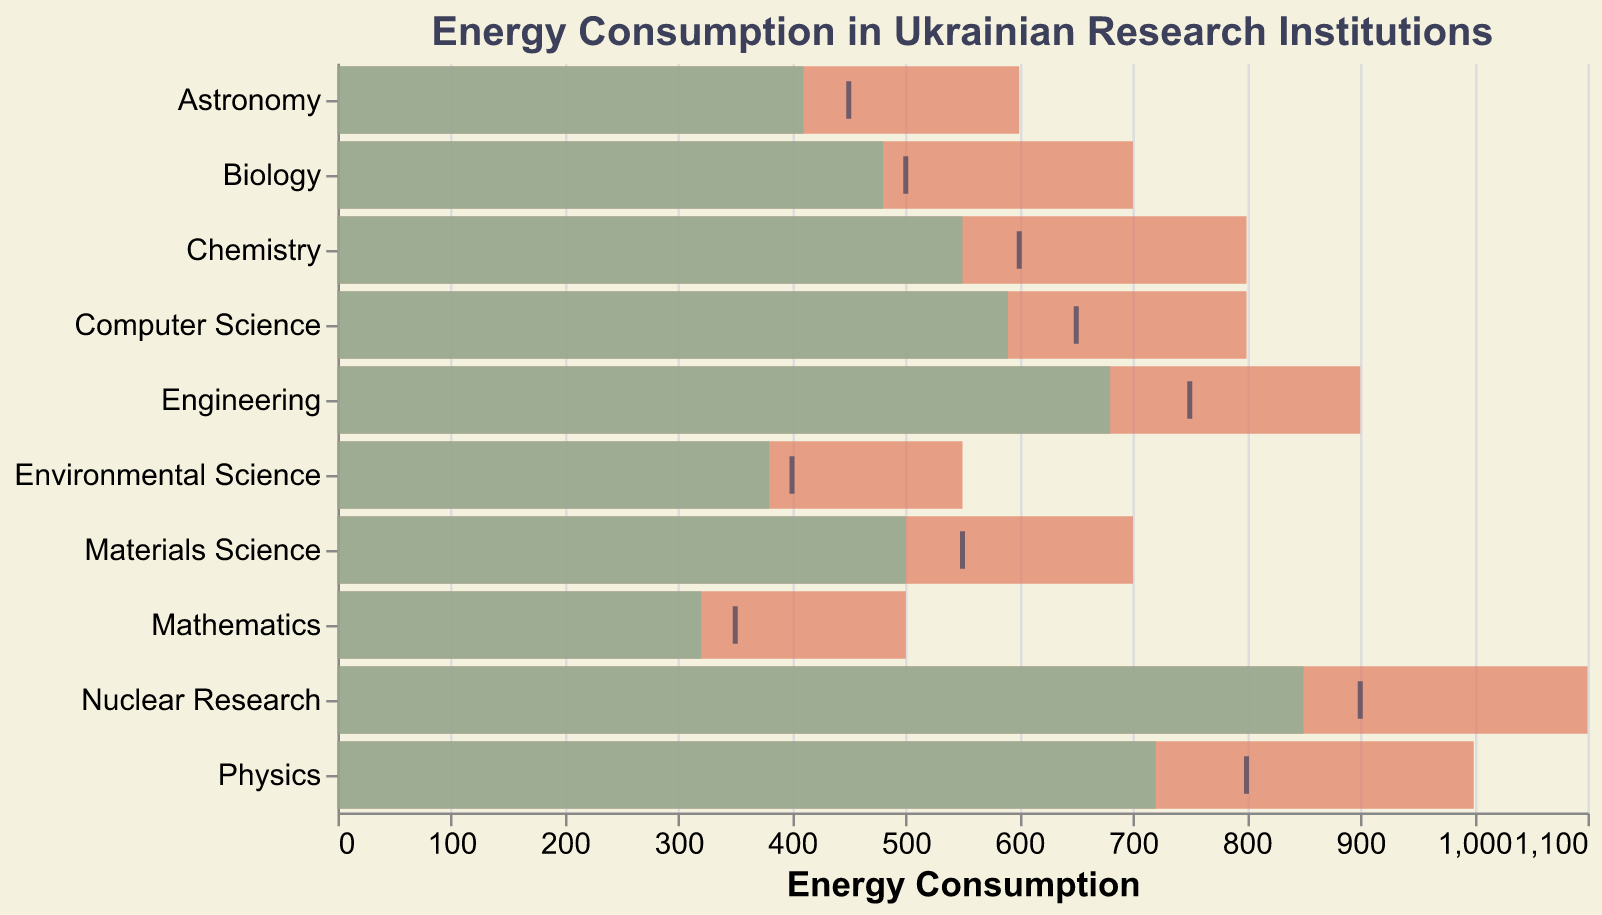What's the title of the chart? The title of the chart is usually located at the top and specifies what the chart is about. In this case, it's "Energy Consumption in Ukrainian Research Institutions".
Answer: Energy Consumption in Ukrainian Research Institutions Which department has the highest actual energy consumption? To determine which department has the highest energy consumption, look at the length of the green bars and find the one that extends the most to the right on the x-axis. Nuclear Research has the longest green bar.
Answer: Nuclear Research How much energy consumption is targeted for the Physics department? The target is marked by a black tick on the x-axis corresponding to the Physics department. The tick aligns with 800.
Answer: 800 By how much does the actual energy consumption for Environmental Science fall short of the target? Calculate the difference between the target and the actual values for Environmental Science. The target is 400, and the actual is 380. The difference is 400 - 380 = 20.
Answer: 20 Which department has an actual energy consumption closest to its targeted amount? To find the closest actual to target values, check the minimal difference between the green bar's end and the black tick. Biology has an actual of 480 and a target of 500, with a difference of 20.
Answer: Biology What is the difference between the maximum and actual energy consumption for Computer Science? Find the values for the maximum and actual consumption for Computer Science and calculate their difference. Max is 800, actual is 590. The difference is 800 - 590 = 210.
Answer: 210 Which department exceeded its target energy consumption the most, and by how much? Compare the actual and target values to find which department exceeded the target the most. Calculate the differences: Nuclear Research (850-900=-50), Physics (720-800=-80), and continue likewise. Nuclear Research exceeded target by the largest amount.
Answer: Nuclear Research, 50 Which department is closest to exceeding its maximum energy consumption, and by how much? Compare the maximum and actual values to determine the smallest margin left before hitting the maximum. Nuclear Research has the highest actual (850) with a maximum of 1100, closest by 250 units before hitting max.
Answer: Nuclear Research, 250 How many departments have actual energy consumption less than their target? Count the departments where the actual value bar is shorter than the target tick. These are Physics, Chemistry, Biology, Engineering, Mathematics, Astronomy, Computer Science, Materials Science, and Environmental Science.
Answer: 9 departments In which department is the difference between maximum and target energy consumption the greatest? Calculate the differences between maximum and target for each department, and find the highest value. For example, Physics: (1000-800=200), Chemistry: (800-600=200), Biology: (700-500=200), etc. They all have the same difference.
Answer: Physics, Chemistry, Biology, Engineering, Computer Science, Materials Science 